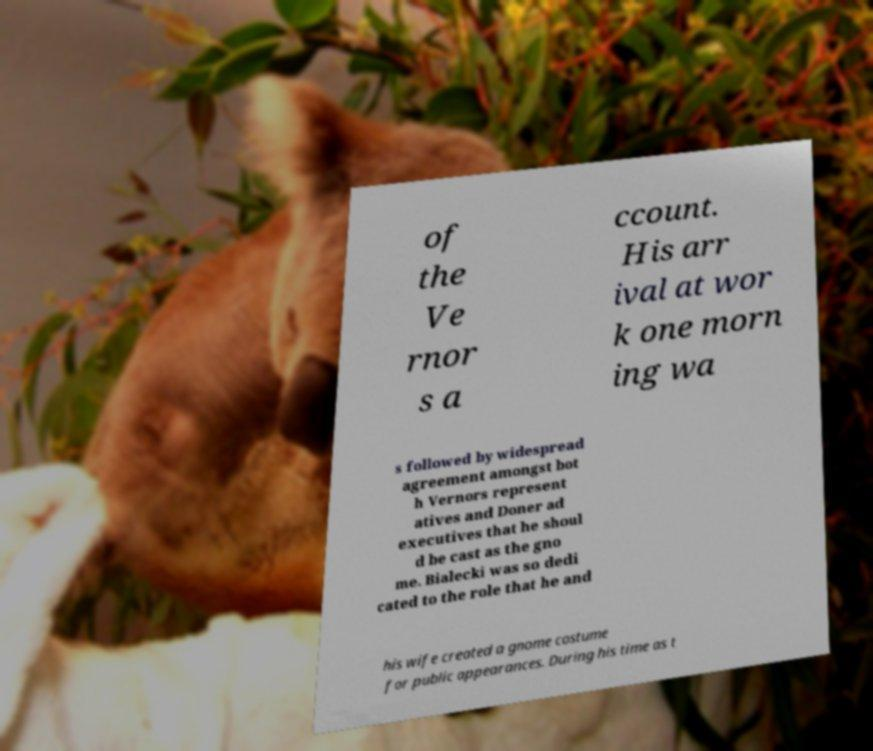Can you accurately transcribe the text from the provided image for me? of the Ve rnor s a ccount. His arr ival at wor k one morn ing wa s followed by widespread agreement amongst bot h Vernors represent atives and Doner ad executives that he shoul d be cast as the gno me. Bialecki was so dedi cated to the role that he and his wife created a gnome costume for public appearances. During his time as t 